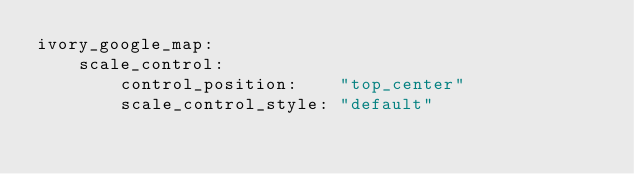Convert code to text. <code><loc_0><loc_0><loc_500><loc_500><_YAML_>ivory_google_map:
    scale_control:
        control_position:    "top_center"
        scale_control_style: "default"
</code> 